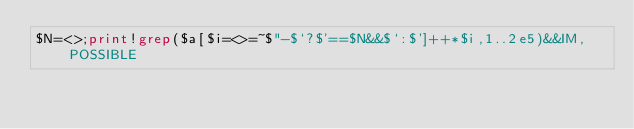<code> <loc_0><loc_0><loc_500><loc_500><_Perl_>$N=<>;print!grep($a[$i=<>=~$"-$`?$'==$N&&$`:$']++*$i,1..2e5)&&IM,POSSIBLE</code> 